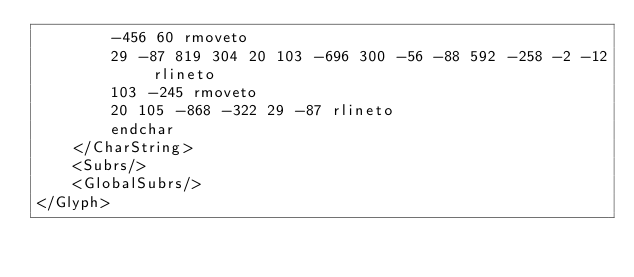Convert code to text. <code><loc_0><loc_0><loc_500><loc_500><_XML_>        -456 60 rmoveto
        29 -87 819 304 20 103 -696 300 -56 -88 592 -258 -2 -12 rlineto
        103 -245 rmoveto
        20 105 -868 -322 29 -87 rlineto
        endchar
    </CharString>
    <Subrs/>
    <GlobalSubrs/>
</Glyph></code> 